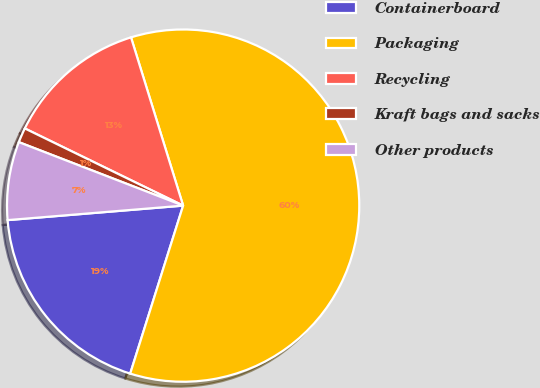Convert chart to OTSL. <chart><loc_0><loc_0><loc_500><loc_500><pie_chart><fcel>Containerboard<fcel>Packaging<fcel>Recycling<fcel>Kraft bags and sacks<fcel>Other products<nl><fcel>18.83%<fcel>59.64%<fcel>13.0%<fcel>1.35%<fcel>7.18%<nl></chart> 